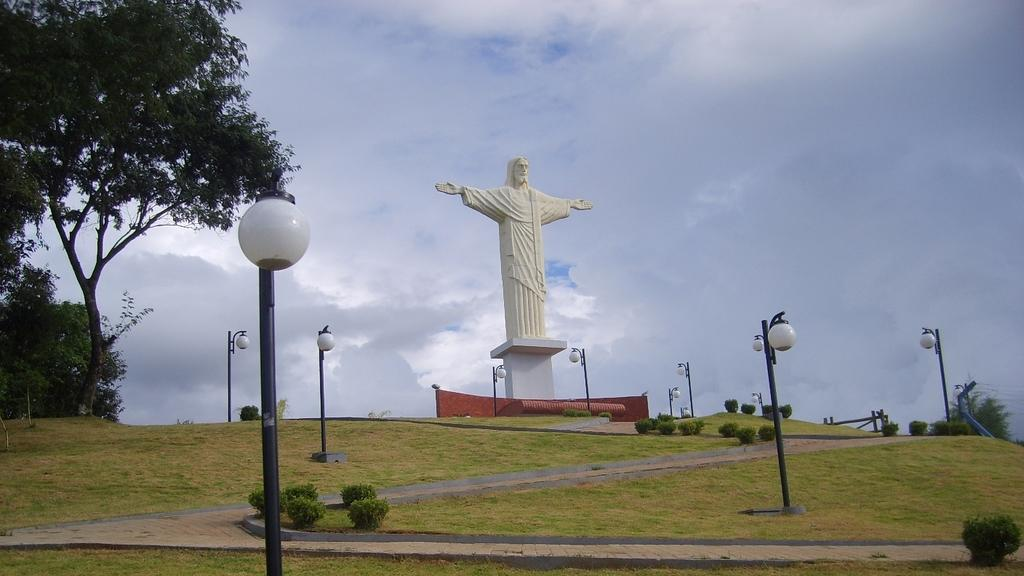What structures can be seen in the image? There are poles and a statue in the image. What objects are present in the image? There are lights and shrubs in the image. What can be seen in the background of the image? There are trees and clouds in the background of the image. What type of bone is visible in the image? There is no bone present in the image. What time of day is it in the image, based on the hour? The image does not provide information about the time of day or the hour. 